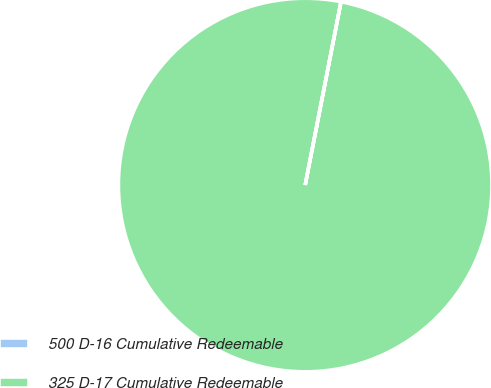Convert chart to OTSL. <chart><loc_0><loc_0><loc_500><loc_500><pie_chart><fcel>500 D-16 Cumulative Redeemable<fcel>325 D-17 Cumulative Redeemable<nl><fcel>0.0%<fcel>100.0%<nl></chart> 